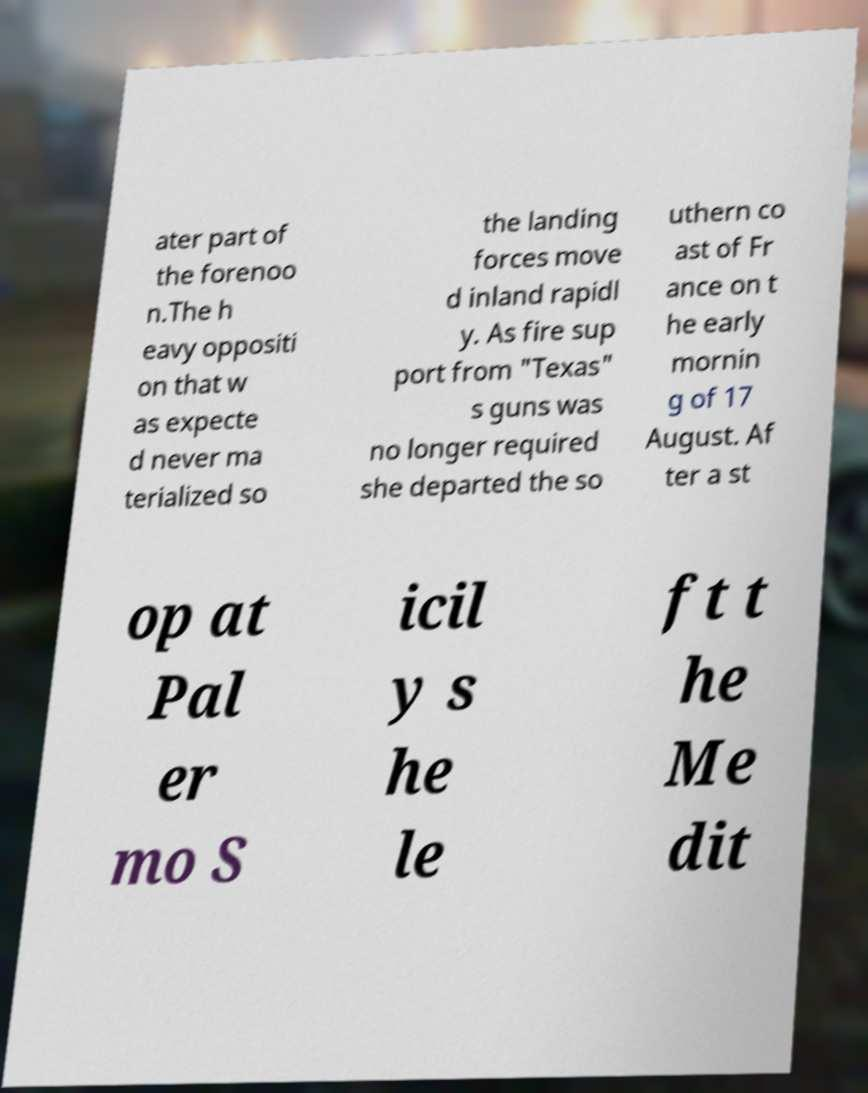What messages or text are displayed in this image? I need them in a readable, typed format. ater part of the forenoo n.The h eavy oppositi on that w as expecte d never ma terialized so the landing forces move d inland rapidl y. As fire sup port from "Texas" s guns was no longer required she departed the so uthern co ast of Fr ance on t he early mornin g of 17 August. Af ter a st op at Pal er mo S icil y s he le ft t he Me dit 